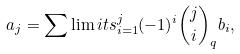<formula> <loc_0><loc_0><loc_500><loc_500>a _ { j } = \sum \lim i t s _ { i = 1 } ^ { j } ( - 1 ) ^ { i } { j \choose i } _ { q } b _ { i } ,</formula> 